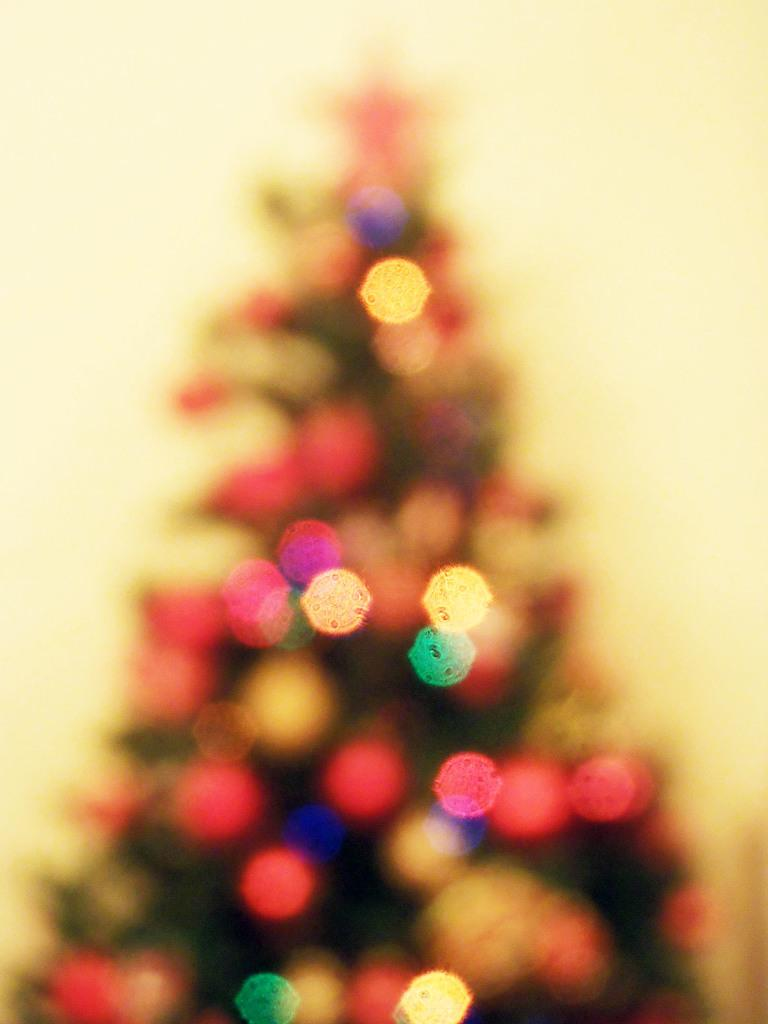What is the main subject of the image? There is a blurry image of a Christmas tree in the image. What else can be seen in the image besides the Christmas tree? There are decorative objects in the image. Can you tell me how the man is gripping the guide in the image? There is no man or guide present in the image; it only features a blurry image of a Christmas tree and decorative objects. 